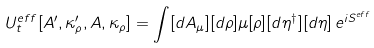Convert formula to latex. <formula><loc_0><loc_0><loc_500><loc_500>U ^ { e f f } _ { t } [ A ^ { \prime } , \kappa _ { \rho } ^ { \prime } , A , \kappa _ { \rho } ] = \int [ d A _ { \mu } ] [ d \rho ] \mu [ \rho ] [ d \eta ^ { \dagger } ] [ d \eta ] \, e ^ { i S ^ { e f f } }</formula> 